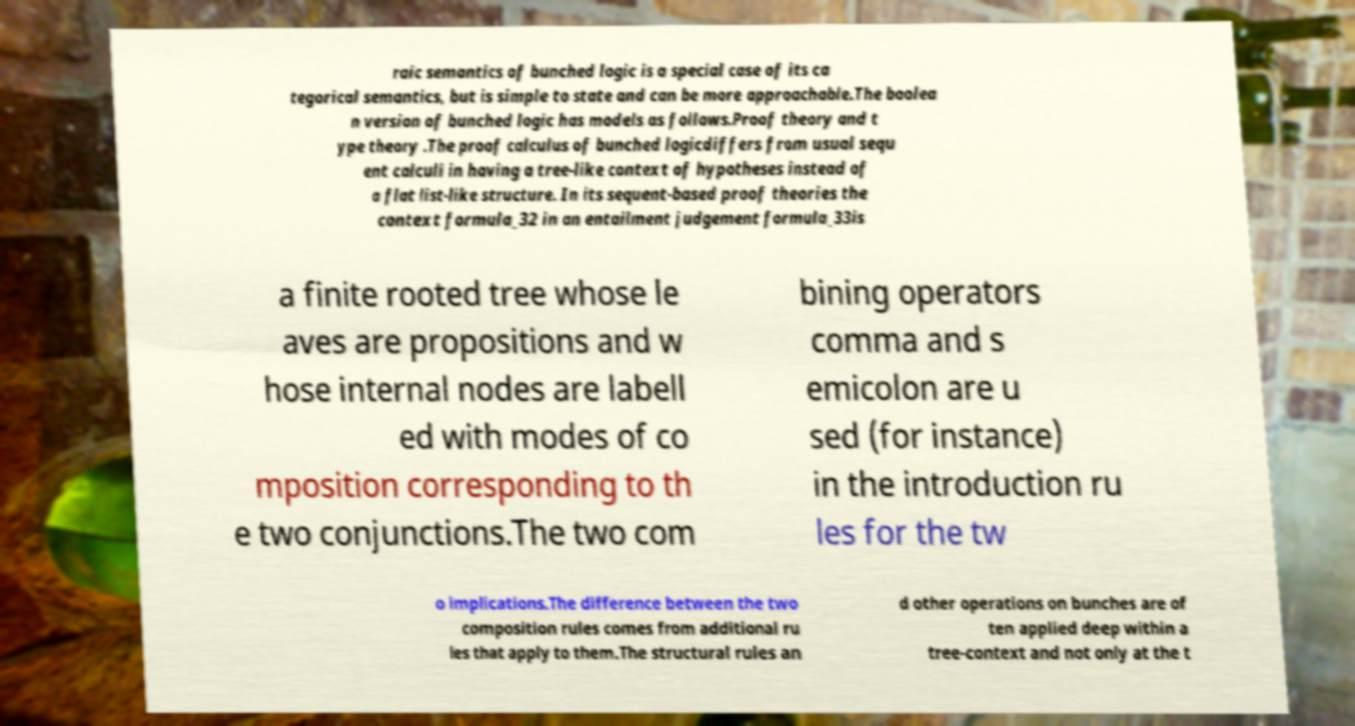Can you accurately transcribe the text from the provided image for me? raic semantics of bunched logic is a special case of its ca tegorical semantics, but is simple to state and can be more approachable.The boolea n version of bunched logic has models as follows.Proof theory and t ype theory .The proof calculus of bunched logicdiffers from usual sequ ent calculi in having a tree-like context of hypotheses instead of a flat list-like structure. In its sequent-based proof theories the context formula_32 in an entailment judgement formula_33is a finite rooted tree whose le aves are propositions and w hose internal nodes are labell ed with modes of co mposition corresponding to th e two conjunctions.The two com bining operators comma and s emicolon are u sed (for instance) in the introduction ru les for the tw o implications.The difference between the two composition rules comes from additional ru les that apply to them.The structural rules an d other operations on bunches are of ten applied deep within a tree-context and not only at the t 